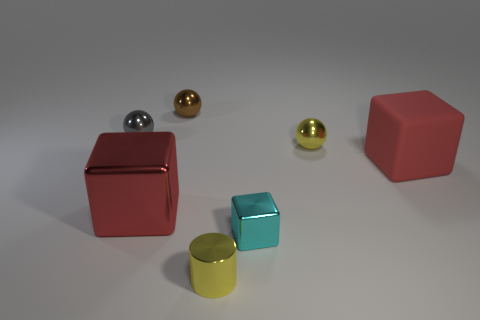Subtract all red cubes. How many were subtracted if there are1red cubes left? 1 Add 3 tiny brown objects. How many objects exist? 10 Subtract all balls. How many objects are left? 4 Subtract all red matte blocks. Subtract all tiny cyan metal things. How many objects are left? 5 Add 1 tiny yellow things. How many tiny yellow things are left? 3 Add 4 small cyan blocks. How many small cyan blocks exist? 5 Subtract 0 cyan spheres. How many objects are left? 7 